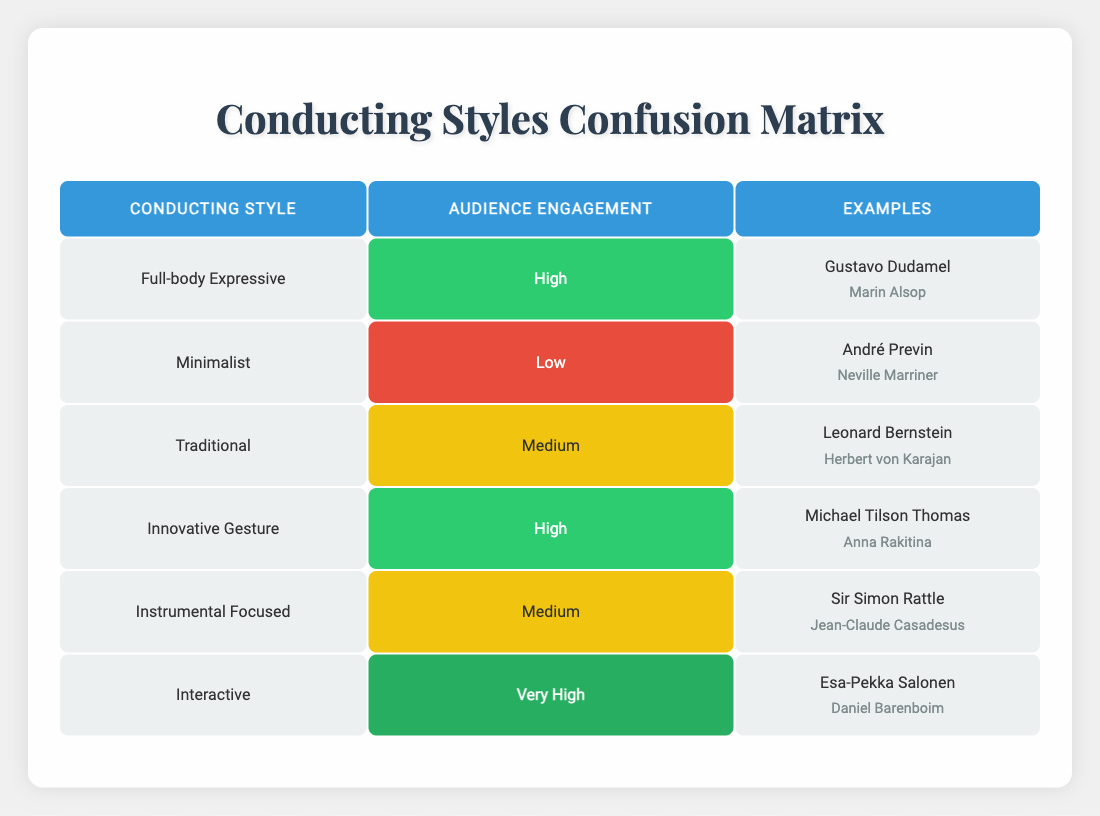What conducting style has the highest audience engagement? The table indicates that the "Interactive" conducting style has the highest audience engagement level listed as "Very High."
Answer: Interactive Which conducting styles have a medium level of audience engagement? According to the table, "Traditional" and "Instrumental Focused" both have an audience engagement level classified as "Medium."
Answer: Traditional, Instrumental Focused Are there any conducting styles associated with low audience engagement? The table lists "Minimalist" as the only conducting style with an audience engagement level labeled as "Low."
Answer: Yes How many conducting styles have high or very high audience engagement? The table shows "Full-body Expressive," "Innovative Gesture," and "Interactive" styles, totaling three styles, categorized as either high or very high engagement.
Answer: Three Which conducting styles are exemplified by Gustavo Dudamel and Esa-Pekka Salonen? From the table, Gustavo Dudamel is linked to the "Full-body Expressive" style and Esa-Pekka Salonen is associated with the "Interactive" style.
Answer: Full-body Expressive, Interactive If we consider only the high engagement styles, what is the average level of engagement for these styles? The high engagement levels are "High" (2 instances for Full-body Expressive and Innovative Gesture) and "Very High" (1 instance for Interactive). Assigning values, High = 1, Very High = 2. Average = (1 + 1 + 2) / 3 = 1.33, which rounds to a level of "High."
Answer: High Is there a conducting style with unique examples not shared by any others? The table shows that "Minimalist" style features André Previn and Neville Marriner, both of which do not appear in the examples of any other styles listed in the table.
Answer: Yes What is the difference in engagement level between the "Interactive" and "Traditional" conducting styles? The "Interactive" has "Very High" engagement, while "Traditional" has "Medium." By ranking the levels, Very High (2) minus Medium (1) equals 1, indicating a difference in engagement level of one category.
Answer: One category How many total conducting styles are represented in the table? The table lists six unique conducting styles, which is the total count of styles presented.
Answer: Six 